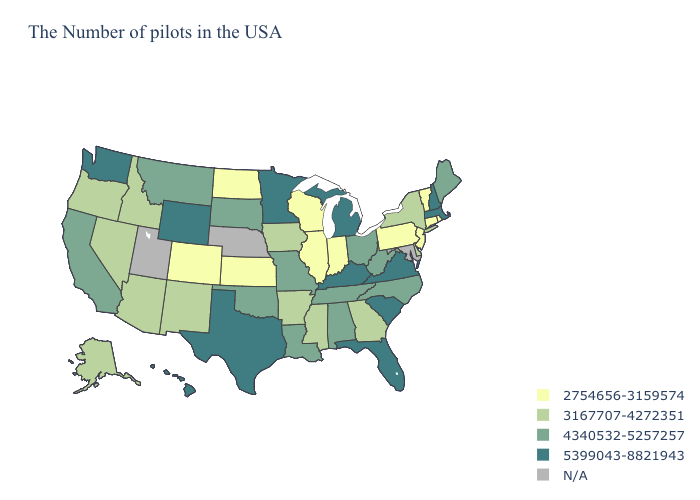What is the value of Indiana?
Write a very short answer. 2754656-3159574. Name the states that have a value in the range 2754656-3159574?
Write a very short answer. Rhode Island, Vermont, Connecticut, New Jersey, Pennsylvania, Indiana, Wisconsin, Illinois, Kansas, North Dakota, Colorado. What is the highest value in the South ?
Keep it brief. 5399043-8821943. What is the lowest value in the USA?
Short answer required. 2754656-3159574. What is the value of Rhode Island?
Concise answer only. 2754656-3159574. Name the states that have a value in the range N/A?
Keep it brief. Maryland, Nebraska, Utah. Is the legend a continuous bar?
Give a very brief answer. No. Does Iowa have the lowest value in the MidWest?
Answer briefly. No. Name the states that have a value in the range 3167707-4272351?
Be succinct. New York, Delaware, Georgia, Mississippi, Arkansas, Iowa, New Mexico, Arizona, Idaho, Nevada, Oregon, Alaska. Among the states that border Iowa , which have the highest value?
Short answer required. Minnesota. What is the value of Arkansas?
Keep it brief. 3167707-4272351. How many symbols are there in the legend?
Short answer required. 5. Does Alaska have the lowest value in the USA?
Quick response, please. No. What is the lowest value in the South?
Short answer required. 3167707-4272351. 